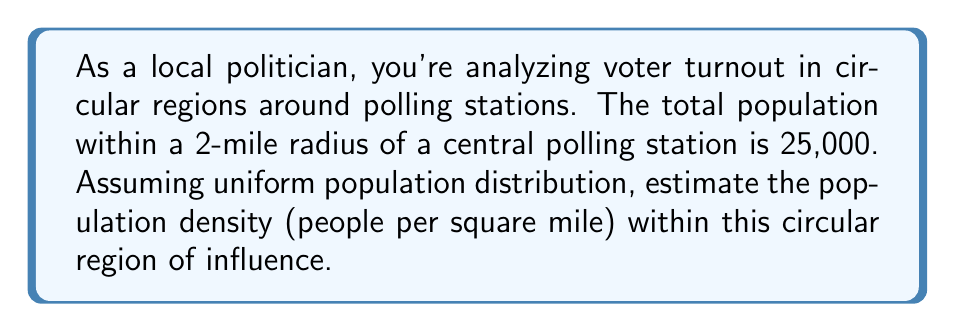What is the answer to this math problem? To solve this problem, we need to follow these steps:

1. Recall the formula for the area of a circle:
   $$A = \pi r^2$$
   where $A$ is the area and $r$ is the radius.

2. Calculate the area of the circular region:
   $$A = \pi (2\text{ miles})^2 = 4\pi \text{ square miles}$$

3. Remember the formula for population density:
   $$\text{Population Density} = \frac{\text{Total Population}}{\text{Area}}$$

4. Substitute the given values:
   $$\text{Population Density} = \frac{25,000\text{ people}}{4\pi \text{ square miles}}$$

5. Simplify:
   $$\text{Population Density} = \frac{25,000}{4\pi} \approx 1,989.44 \text{ people per square mile}$$

This calculation provides an estimate of the population density within the 2-mile radius of the polling station, assuming uniform distribution. As a politician, this information can be valuable for planning resource allocation, understanding voter accessibility, and making informed decisions about polling station locations.
Answer: The estimated population density is approximately 1,989 people per square mile. 